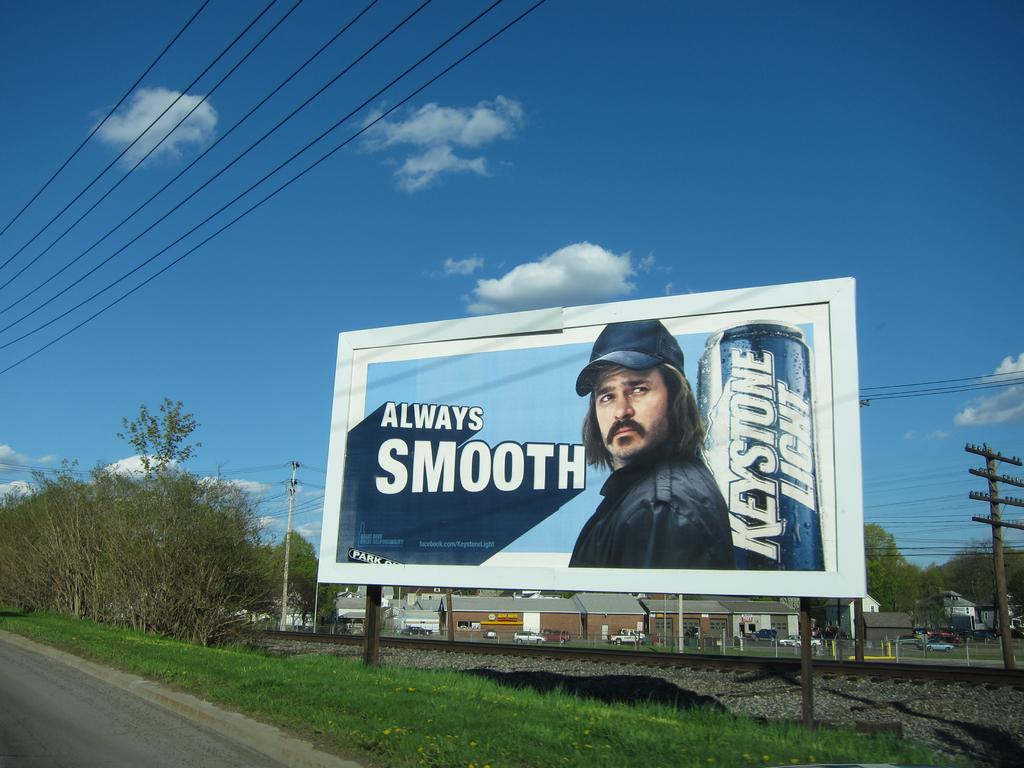<image>
Summarize the visual content of the image. A billboard ad with "always smooth", advertising beer. 